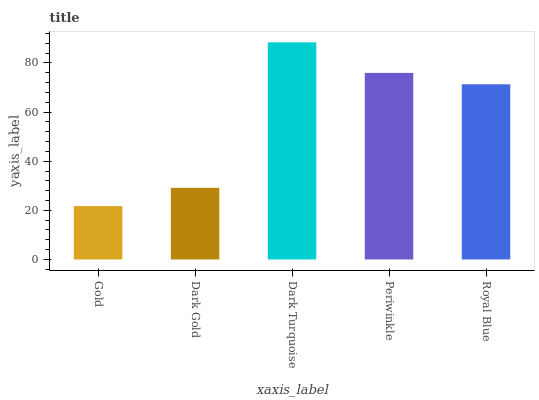Is Gold the minimum?
Answer yes or no. Yes. Is Dark Turquoise the maximum?
Answer yes or no. Yes. Is Dark Gold the minimum?
Answer yes or no. No. Is Dark Gold the maximum?
Answer yes or no. No. Is Dark Gold greater than Gold?
Answer yes or no. Yes. Is Gold less than Dark Gold?
Answer yes or no. Yes. Is Gold greater than Dark Gold?
Answer yes or no. No. Is Dark Gold less than Gold?
Answer yes or no. No. Is Royal Blue the high median?
Answer yes or no. Yes. Is Royal Blue the low median?
Answer yes or no. Yes. Is Gold the high median?
Answer yes or no. No. Is Dark Turquoise the low median?
Answer yes or no. No. 